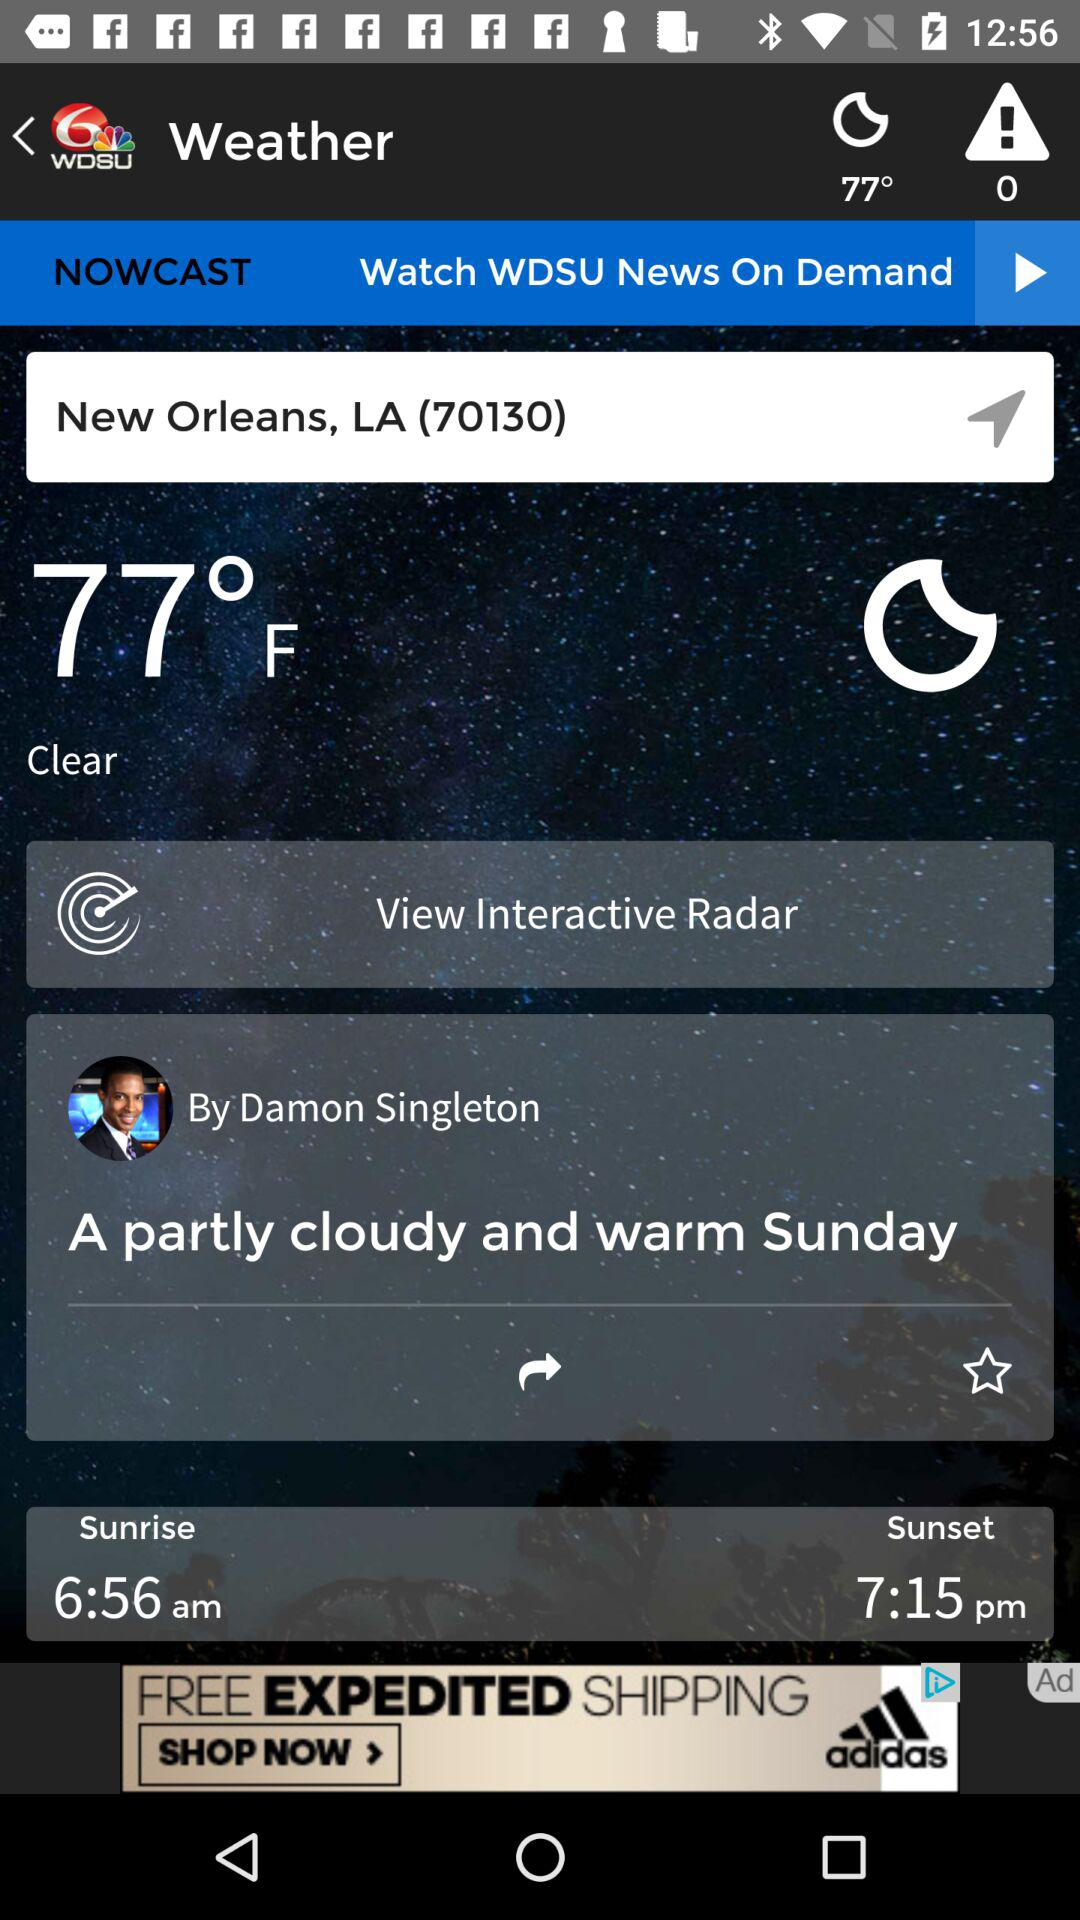How many degrees Fahrenheit is the current temperature?
Answer the question using a single word or phrase. 77°F 